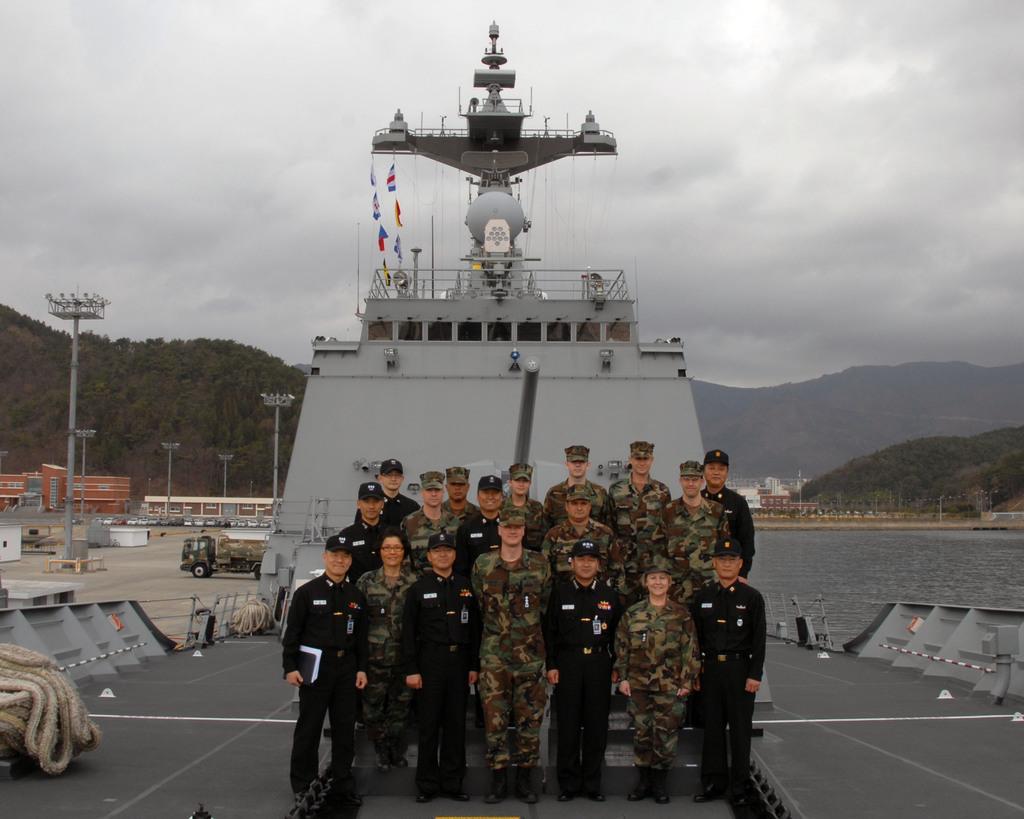Please provide a concise description of this image. This picture describes about group of people, they are standing on the ship, and the ship is in the water, in the background we can see few vehicles on the road, and also we can see few poles, buildings, trees and hills. 